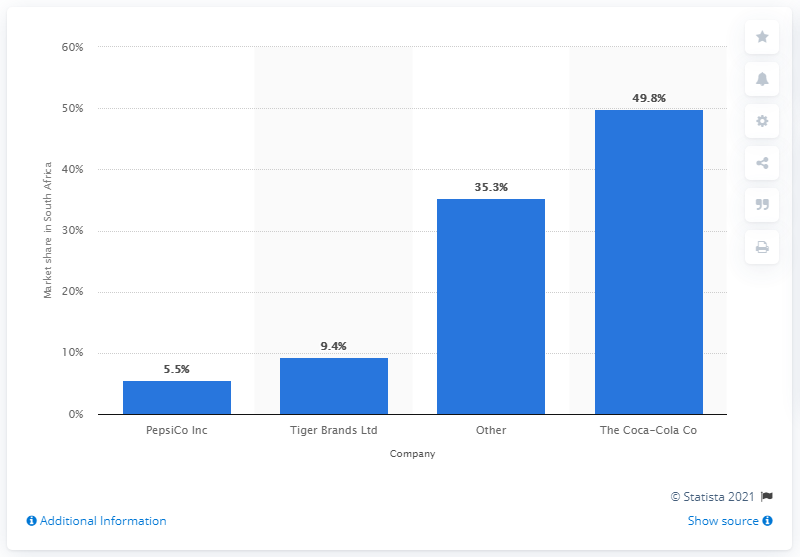Identify some key points in this picture. In 2010, Coca-Cola held a market share of 49.8% in South Africa. 